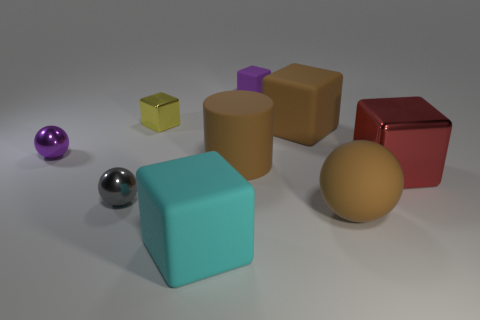Subtract all large brown matte cubes. How many cubes are left? 4 Subtract all brown blocks. How many blocks are left? 4 Subtract all gray cubes. Subtract all green balls. How many cubes are left? 5 Add 1 large cyan rubber objects. How many objects exist? 10 Subtract all cylinders. How many objects are left? 8 Add 7 yellow things. How many yellow things are left? 8 Add 4 purple metal balls. How many purple metal balls exist? 5 Subtract 1 purple spheres. How many objects are left? 8 Subtract all brown matte cubes. Subtract all cyan shiny objects. How many objects are left? 8 